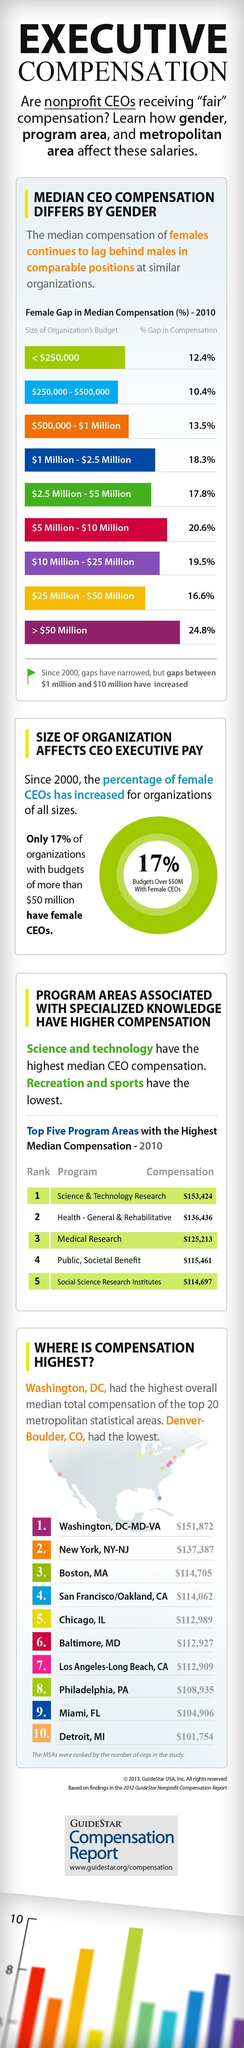Point out several critical features in this image. The program area with the second-highest compensation in dollars is Health - General & Rehabilitative. The inverse number of Women CEOs in companies with a wealth of higher than a 50 million is 83. The median salary for women working in the second largest organization has decreased by 16.6%. The program area with the third-highest compensation in dollars is medical research. The organization for which female gap compensation is the fourth highest has a size of $1 Million - $2.5 Million. 